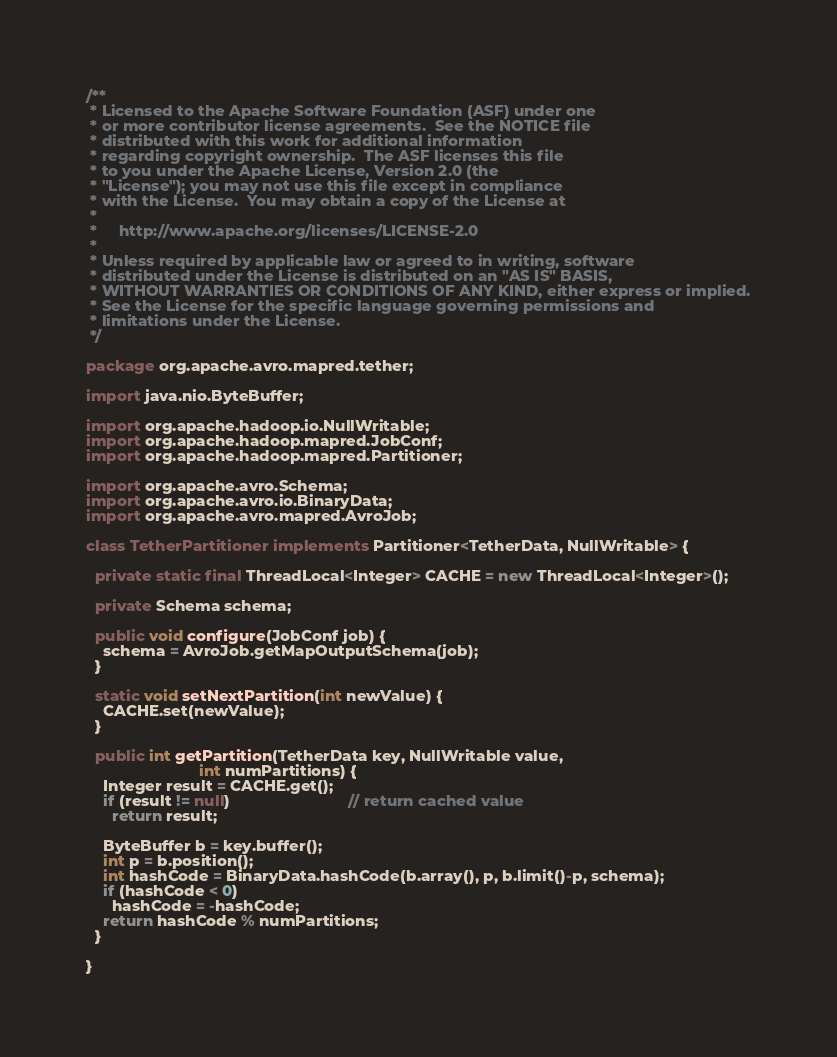Convert code to text. <code><loc_0><loc_0><loc_500><loc_500><_Java_>/**
 * Licensed to the Apache Software Foundation (ASF) under one
 * or more contributor license agreements.  See the NOTICE file
 * distributed with this work for additional information
 * regarding copyright ownership.  The ASF licenses this file
 * to you under the Apache License, Version 2.0 (the
 * "License"); you may not use this file except in compliance
 * with the License.  You may obtain a copy of the License at
 *
 *     http://www.apache.org/licenses/LICENSE-2.0
 *
 * Unless required by applicable law or agreed to in writing, software
 * distributed under the License is distributed on an "AS IS" BASIS,
 * WITHOUT WARRANTIES OR CONDITIONS OF ANY KIND, either express or implied.
 * See the License for the specific language governing permissions and
 * limitations under the License.
 */

package org.apache.avro.mapred.tether;

import java.nio.ByteBuffer;

import org.apache.hadoop.io.NullWritable;
import org.apache.hadoop.mapred.JobConf;
import org.apache.hadoop.mapred.Partitioner;

import org.apache.avro.Schema;
import org.apache.avro.io.BinaryData;
import org.apache.avro.mapred.AvroJob;

class TetherPartitioner implements Partitioner<TetherData, NullWritable> {
  
  private static final ThreadLocal<Integer> CACHE = new ThreadLocal<Integer>();

  private Schema schema;

  public void configure(JobConf job) {
    schema = AvroJob.getMapOutputSchema(job);
  }

  static void setNextPartition(int newValue) {
    CACHE.set(newValue);
  }

  public int getPartition(TetherData key, NullWritable value,
                          int numPartitions) {
    Integer result = CACHE.get();
    if (result != null)                           // return cached value
      return result;

    ByteBuffer b = key.buffer();
    int p = b.position();
    int hashCode = BinaryData.hashCode(b.array(), p, b.limit()-p, schema);
    if (hashCode < 0)
      hashCode = -hashCode;
    return hashCode % numPartitions;
  }

}
</code> 